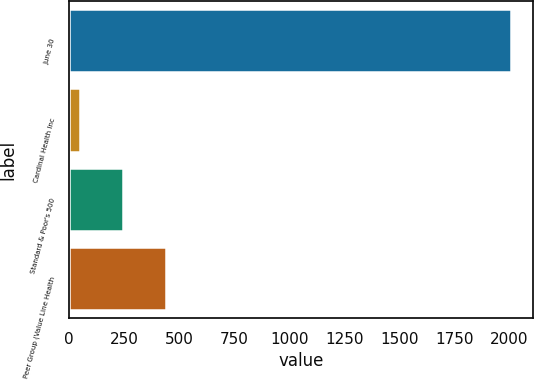Convert chart to OTSL. <chart><loc_0><loc_0><loc_500><loc_500><bar_chart><fcel>June 30<fcel>Cardinal Health Inc<fcel>Standard & Poor's 500<fcel>Peer Group (Value Line Health<nl><fcel>2009<fcel>49.03<fcel>245.03<fcel>441.03<nl></chart> 